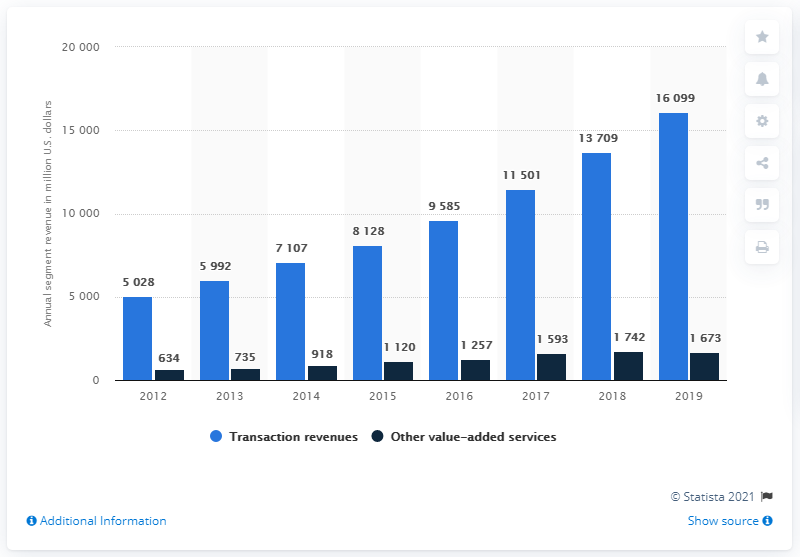Compare the growth rates of transaction revenues and other value-added services from 2012 to 2019. Analyzing the chart from 2012 to 2019, we see that transaction revenues have experienced a substantial growth rate, rising from $5,028 million to $16,099 million. In contrast, revenues from other value-added services grew more modestly from $634 million to $1,673 million. Although both sectors show growth, transaction revenues have escalated at a much faster pace, which indicates a more robust expansion in that area of the business. 